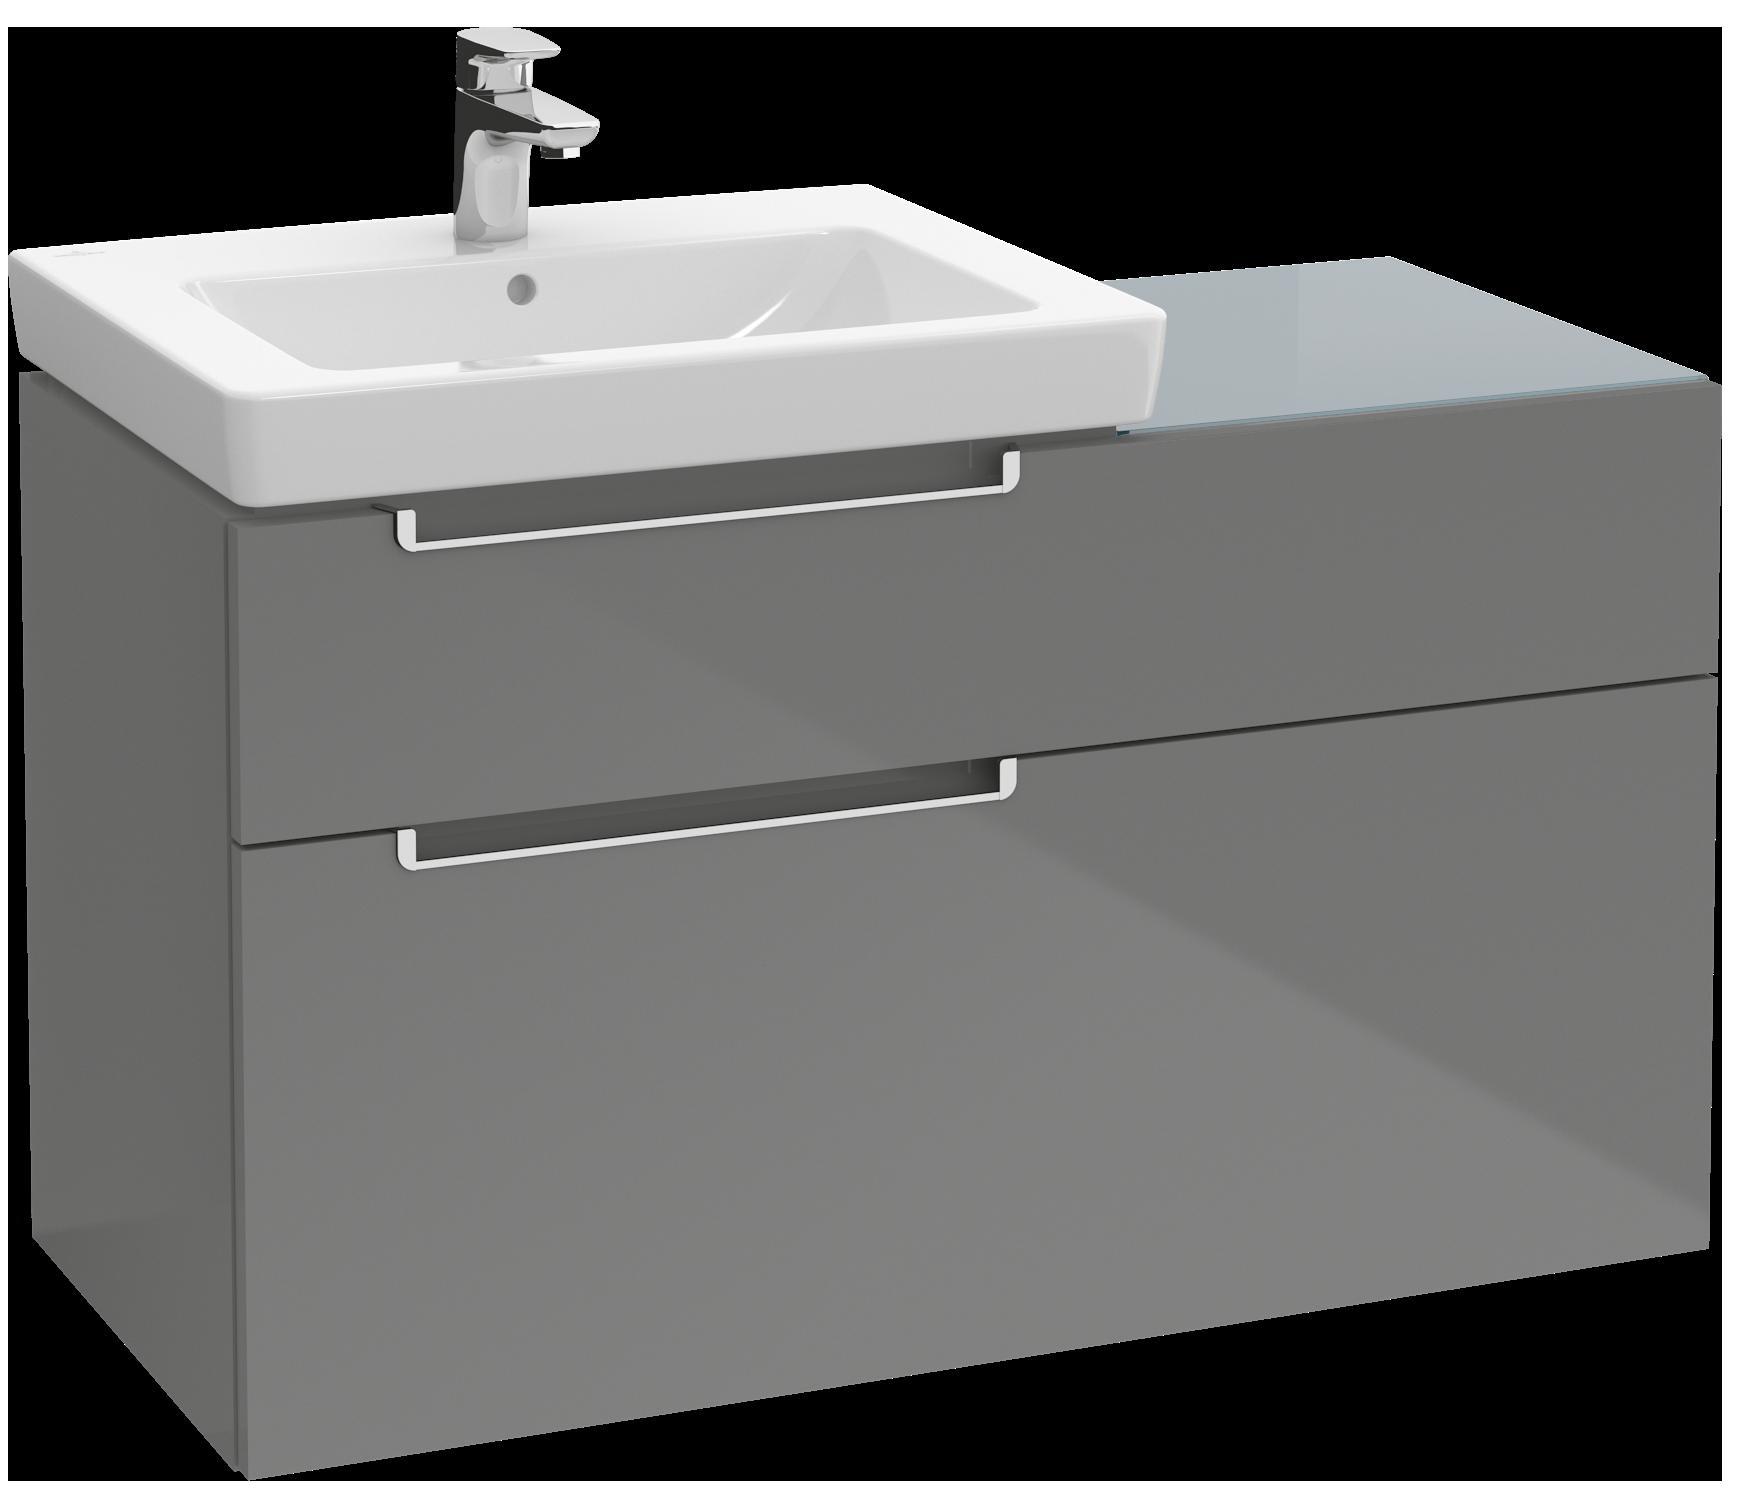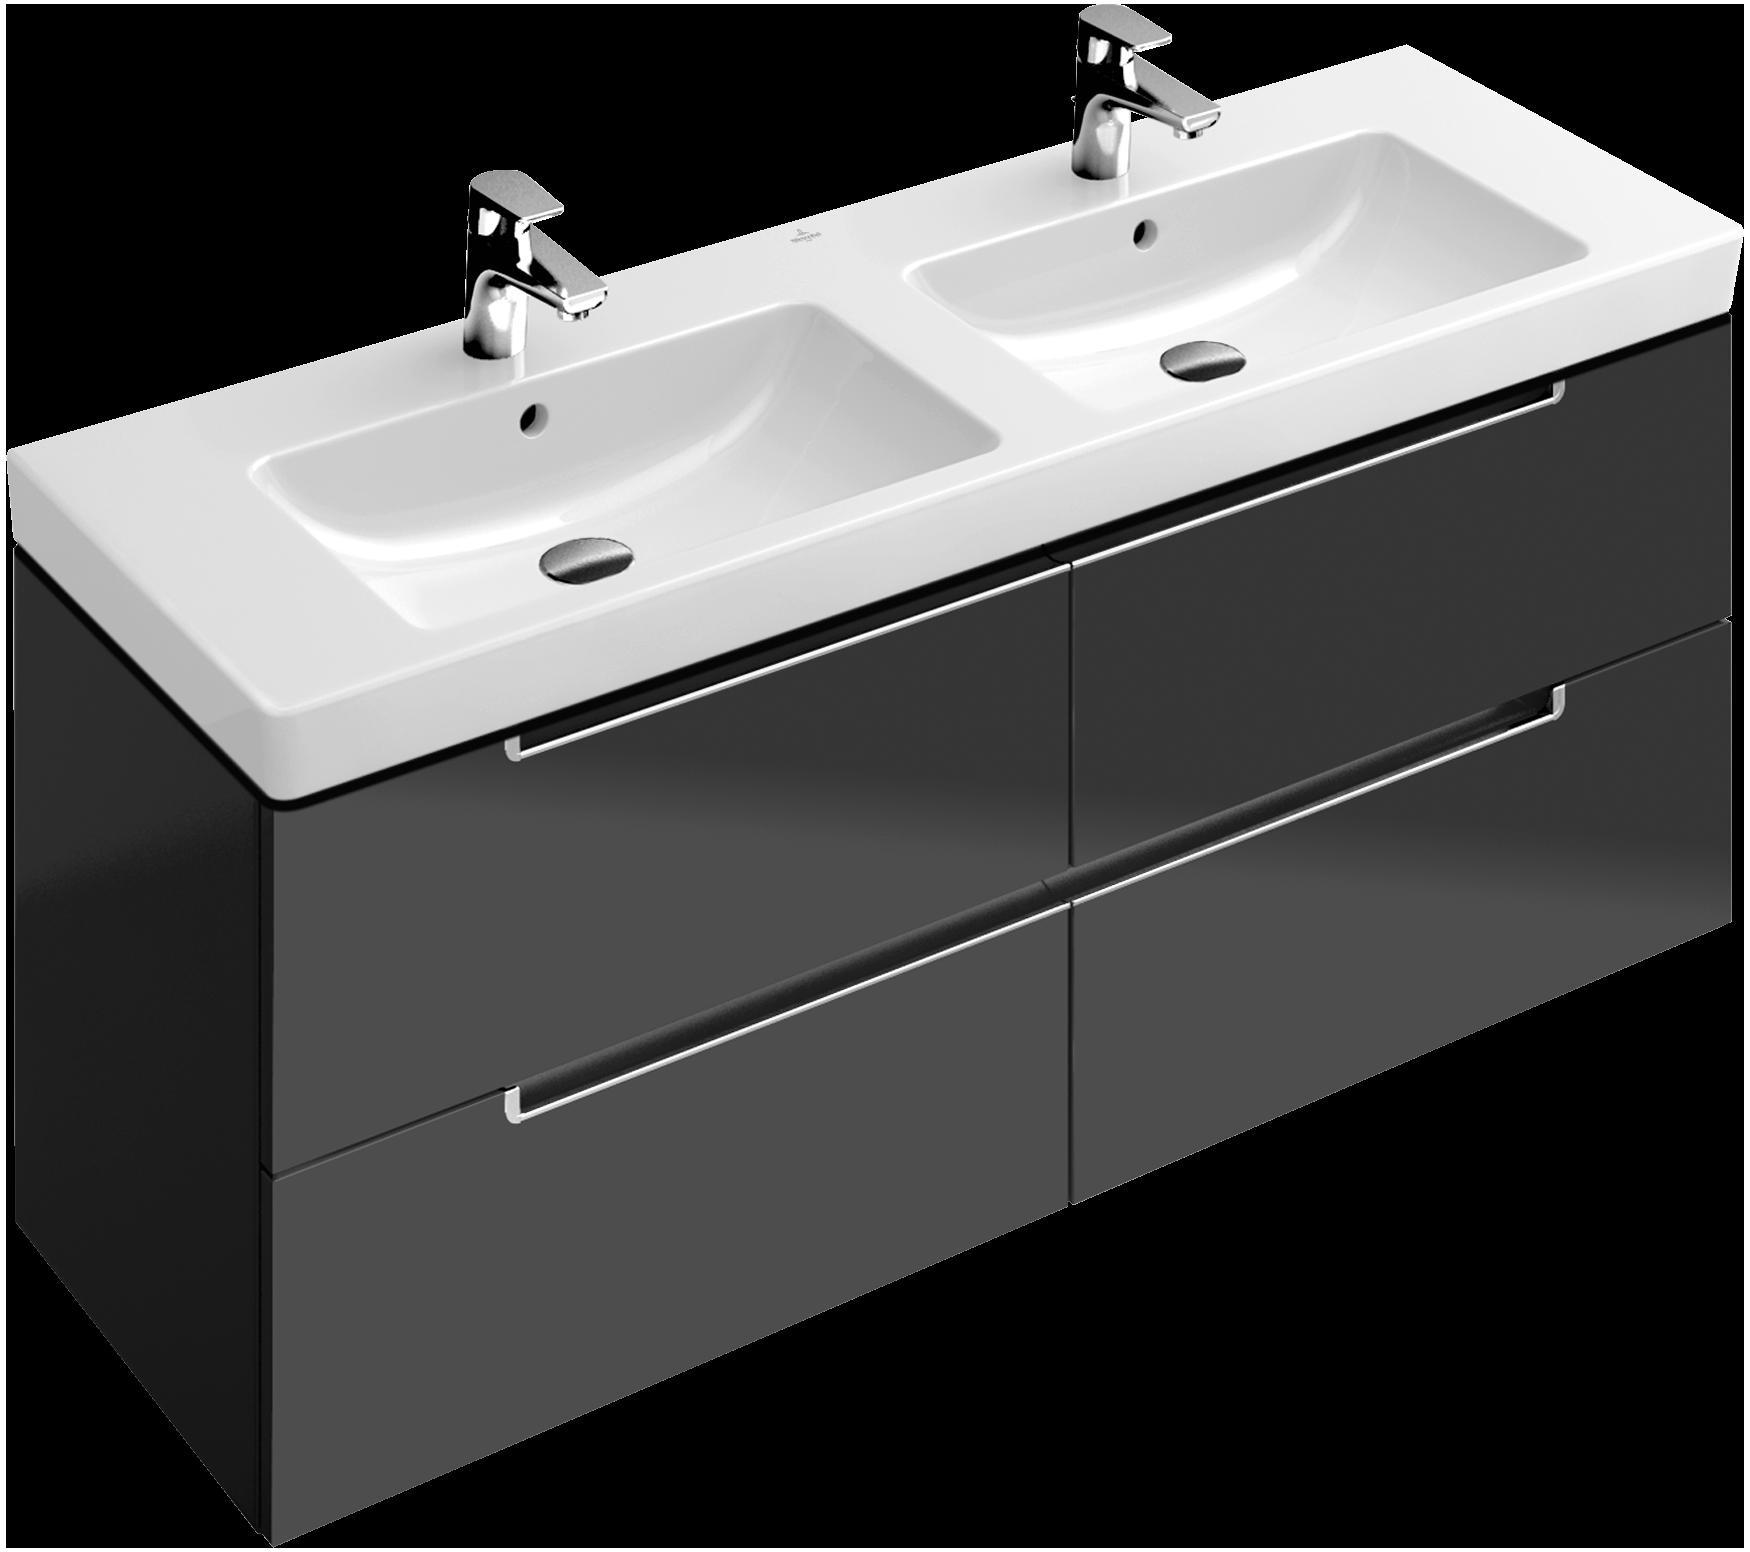The first image is the image on the left, the second image is the image on the right. For the images displayed, is the sentence "Three faucets are visible." factually correct? Answer yes or no. Yes. The first image is the image on the left, the second image is the image on the right. Evaluate the accuracy of this statement regarding the images: "There are three faucets.". Is it true? Answer yes or no. Yes. 